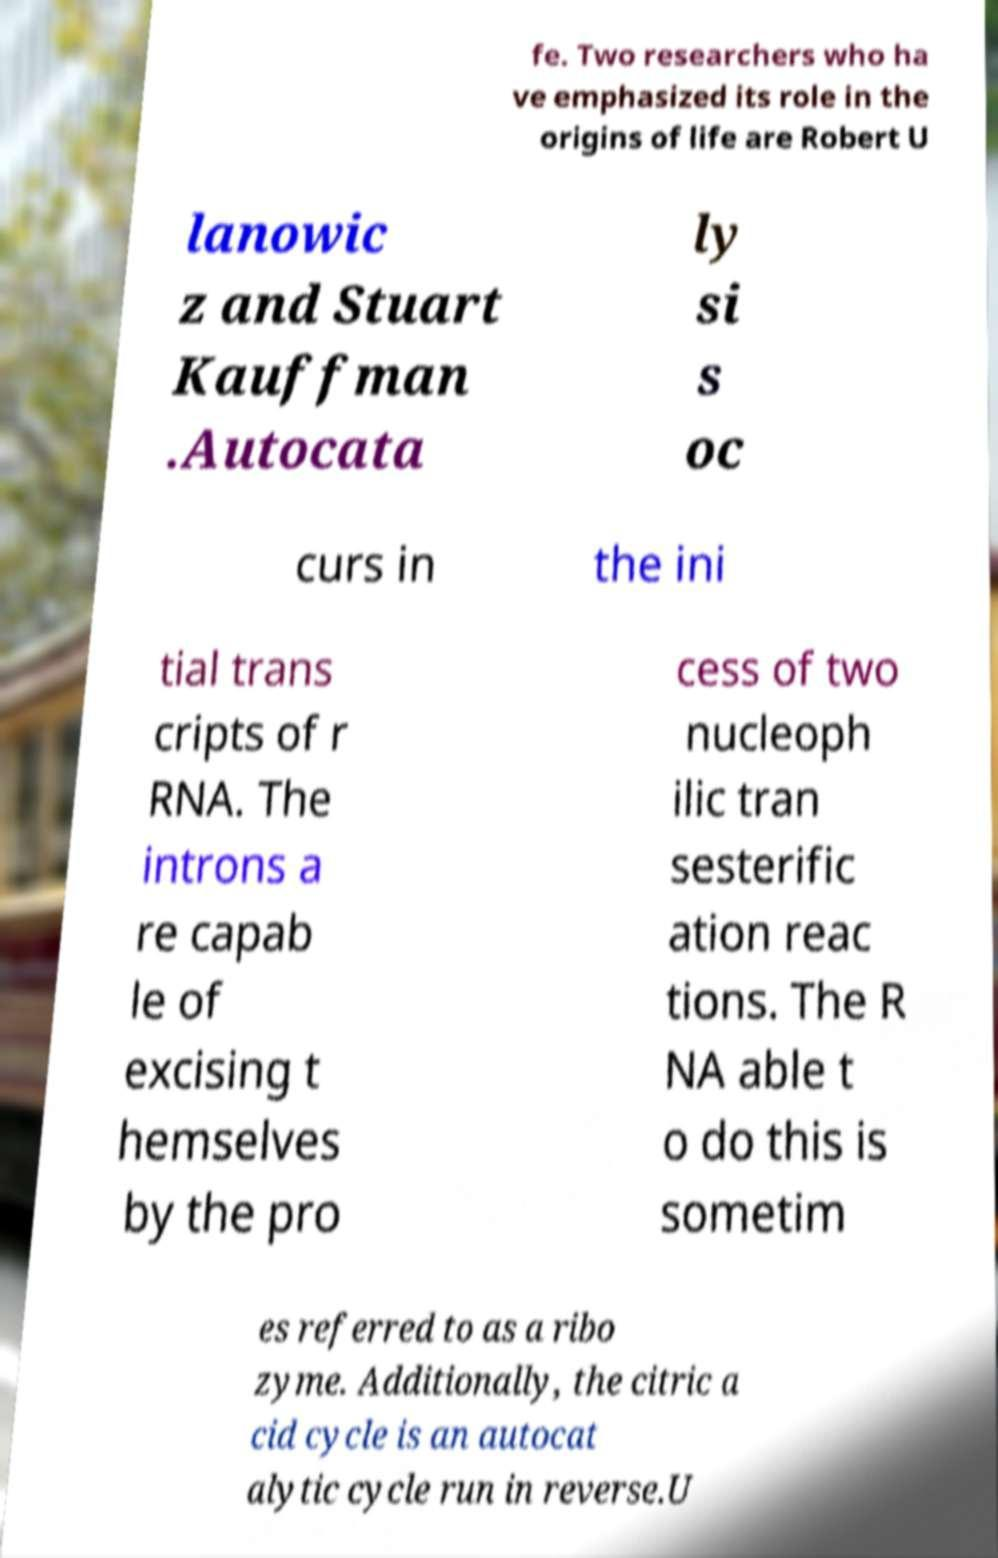I need the written content from this picture converted into text. Can you do that? fe. Two researchers who ha ve emphasized its role in the origins of life are Robert U lanowic z and Stuart Kauffman .Autocata ly si s oc curs in the ini tial trans cripts of r RNA. The introns a re capab le of excising t hemselves by the pro cess of two nucleoph ilic tran sesterific ation reac tions. The R NA able t o do this is sometim es referred to as a ribo zyme. Additionally, the citric a cid cycle is an autocat alytic cycle run in reverse.U 